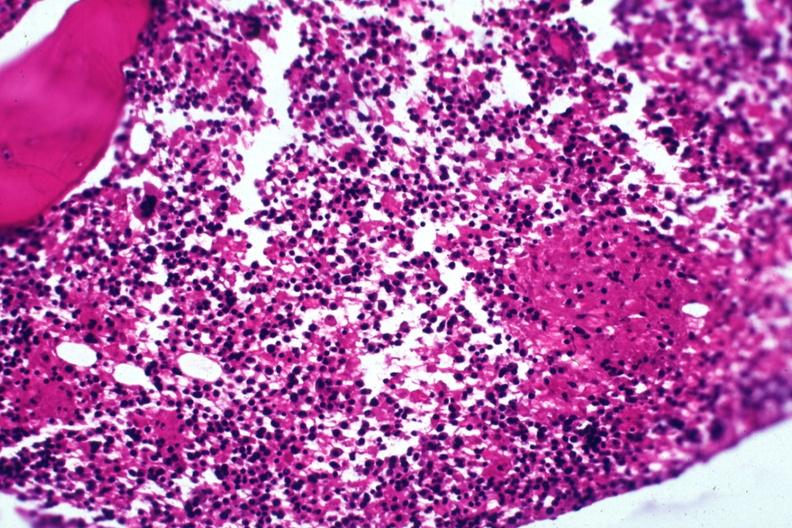s siamese twins present?
Answer the question using a single word or phrase. No 